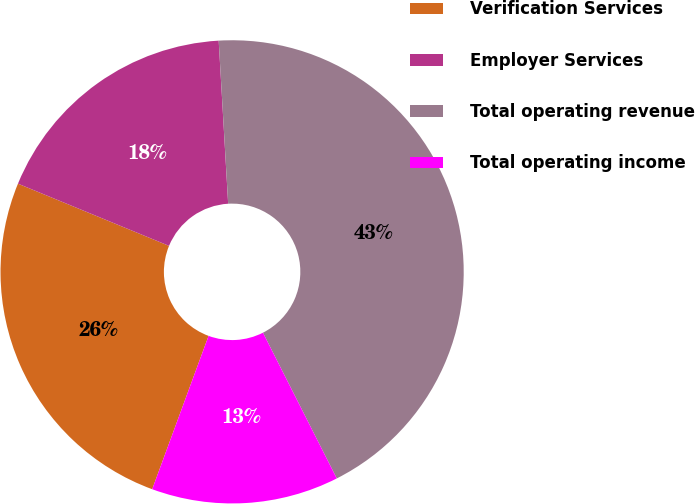Convert chart. <chart><loc_0><loc_0><loc_500><loc_500><pie_chart><fcel>Verification Services<fcel>Employer Services<fcel>Total operating revenue<fcel>Total operating income<nl><fcel>25.61%<fcel>17.86%<fcel>43.46%<fcel>13.07%<nl></chart> 